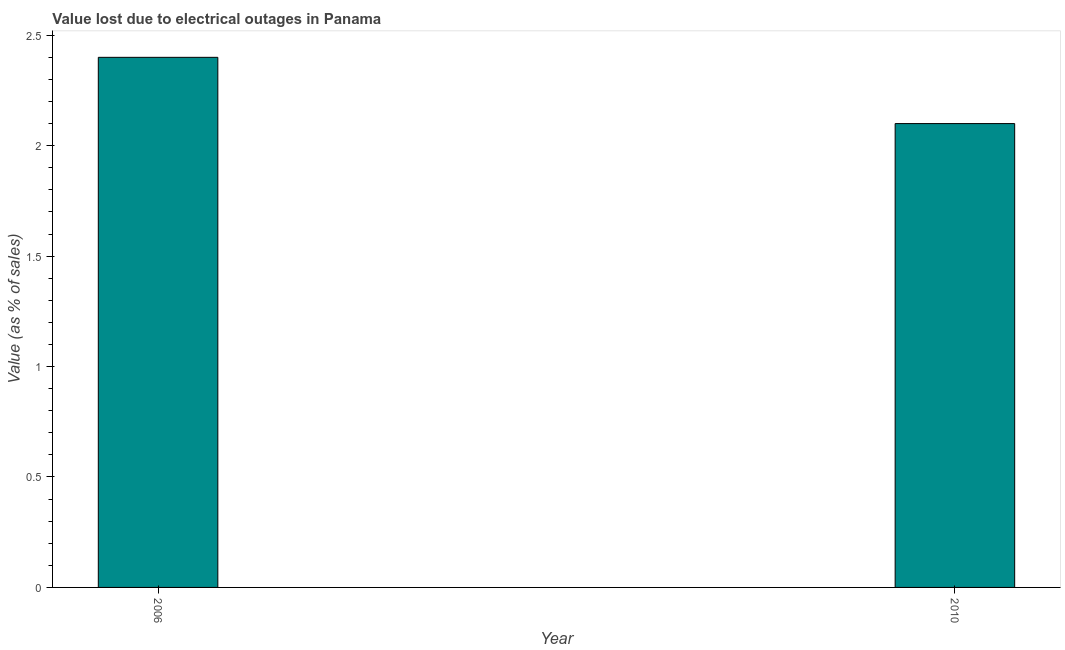Does the graph contain any zero values?
Provide a succinct answer. No. Does the graph contain grids?
Your answer should be compact. No. What is the title of the graph?
Provide a succinct answer. Value lost due to electrical outages in Panama. What is the label or title of the Y-axis?
Provide a short and direct response. Value (as % of sales). In which year was the value lost due to electrical outages maximum?
Ensure brevity in your answer.  2006. What is the sum of the value lost due to electrical outages?
Offer a terse response. 4.5. What is the average value lost due to electrical outages per year?
Your response must be concise. 2.25. What is the median value lost due to electrical outages?
Make the answer very short. 2.25. Do a majority of the years between 2006 and 2010 (inclusive) have value lost due to electrical outages greater than 2.4 %?
Ensure brevity in your answer.  No. What is the ratio of the value lost due to electrical outages in 2006 to that in 2010?
Offer a very short reply. 1.14. How many bars are there?
Keep it short and to the point. 2. Are the values on the major ticks of Y-axis written in scientific E-notation?
Ensure brevity in your answer.  No. What is the Value (as % of sales) of 2010?
Offer a terse response. 2.1. What is the difference between the Value (as % of sales) in 2006 and 2010?
Keep it short and to the point. 0.3. What is the ratio of the Value (as % of sales) in 2006 to that in 2010?
Offer a terse response. 1.14. 